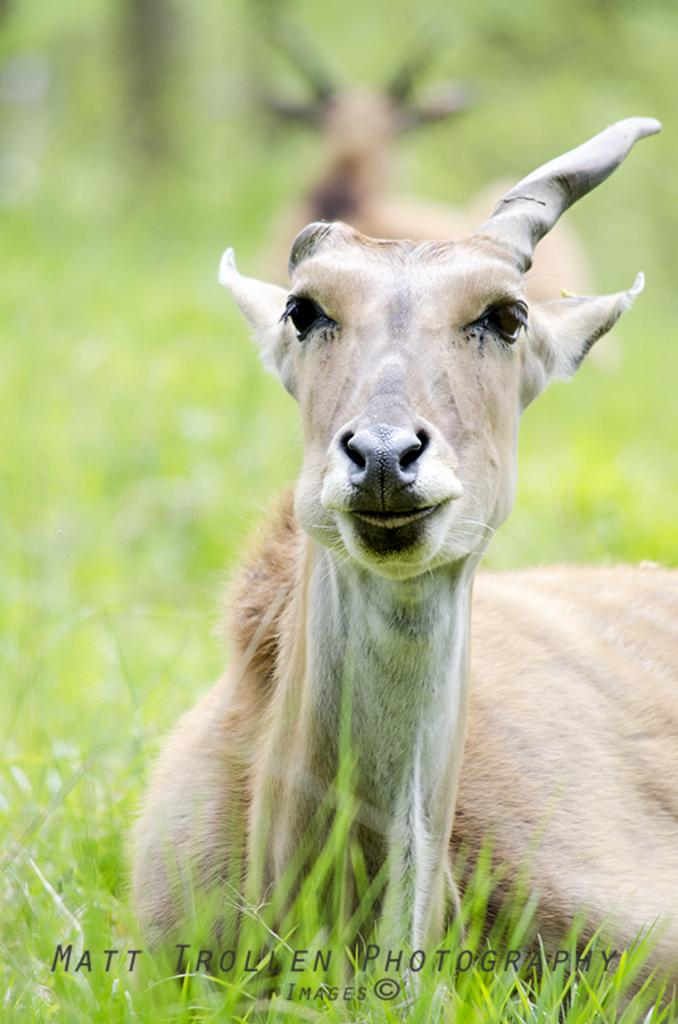What animals can be seen in the image? There are two deers in the image. Where are the deers located? The deers are sitting on the grassland. What type of boundary can be seen surrounding the deers in the image? There is no boundary visible in the image; it features two deers sitting on the grassland. Can you see any dinosaurs interacting with the deers in the image? There are no dinosaurs present in the image; it features two deers sitting on the grassland. 